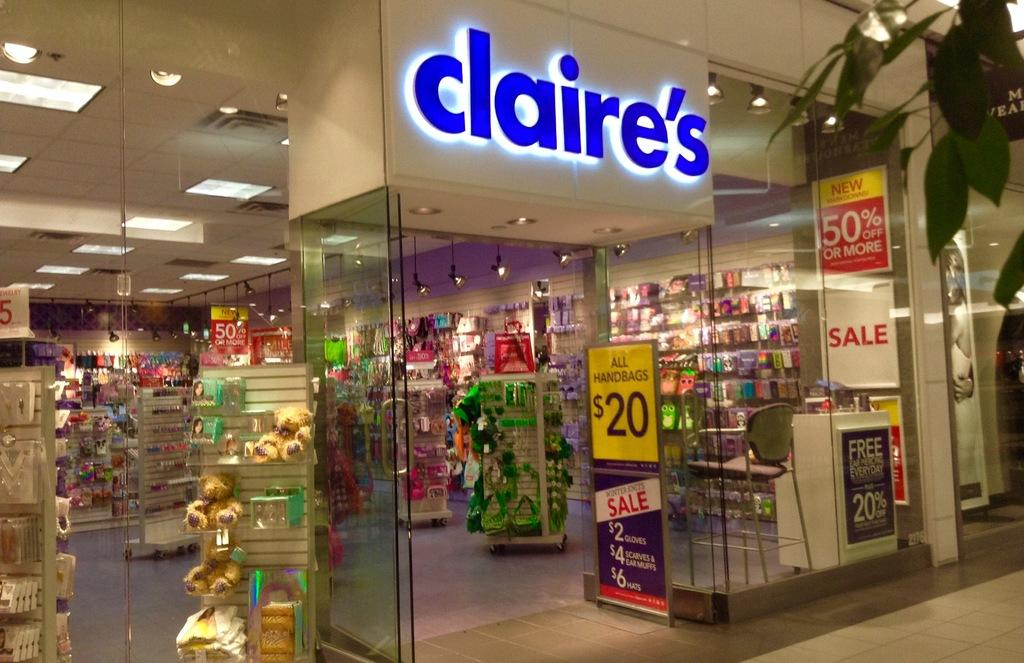<image>
Offer a succinct explanation of the picture presented. A claire's store in a mall advertising various sales at the entrance 